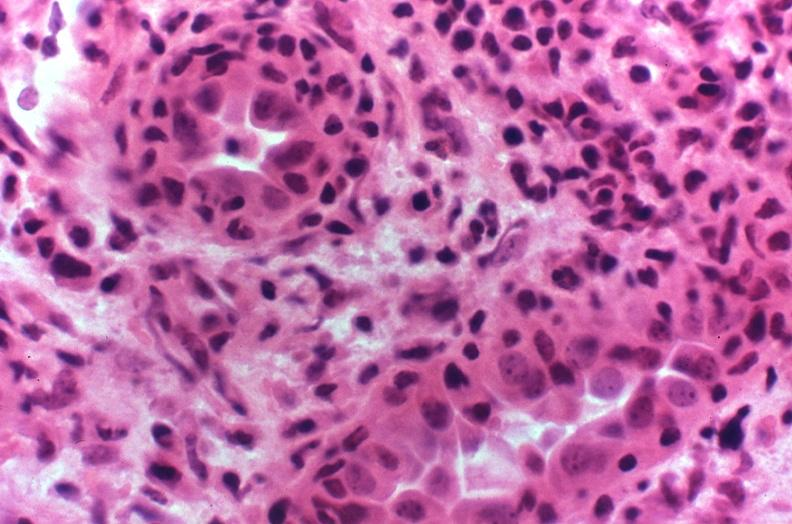what does this image show?
Answer the question using a single word or phrase. Kidney transplant rejection 